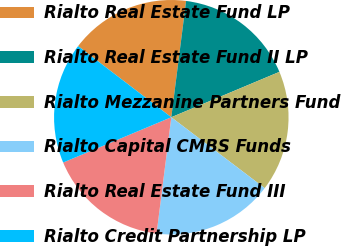Convert chart to OTSL. <chart><loc_0><loc_0><loc_500><loc_500><pie_chart><fcel>Rialto Real Estate Fund LP<fcel>Rialto Real Estate Fund II LP<fcel>Rialto Mezzanine Partners Fund<fcel>Rialto Capital CMBS Funds<fcel>Rialto Real Estate Fund III<fcel>Rialto Credit Partnership LP<nl><fcel>16.64%<fcel>16.66%<fcel>16.66%<fcel>16.67%<fcel>16.68%<fcel>16.69%<nl></chart> 